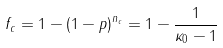Convert formula to latex. <formula><loc_0><loc_0><loc_500><loc_500>f _ { c } = 1 - \left ( 1 - p \right ) ^ { n _ { c } } = 1 - \frac { 1 } { \kappa _ { 0 } - 1 }</formula> 